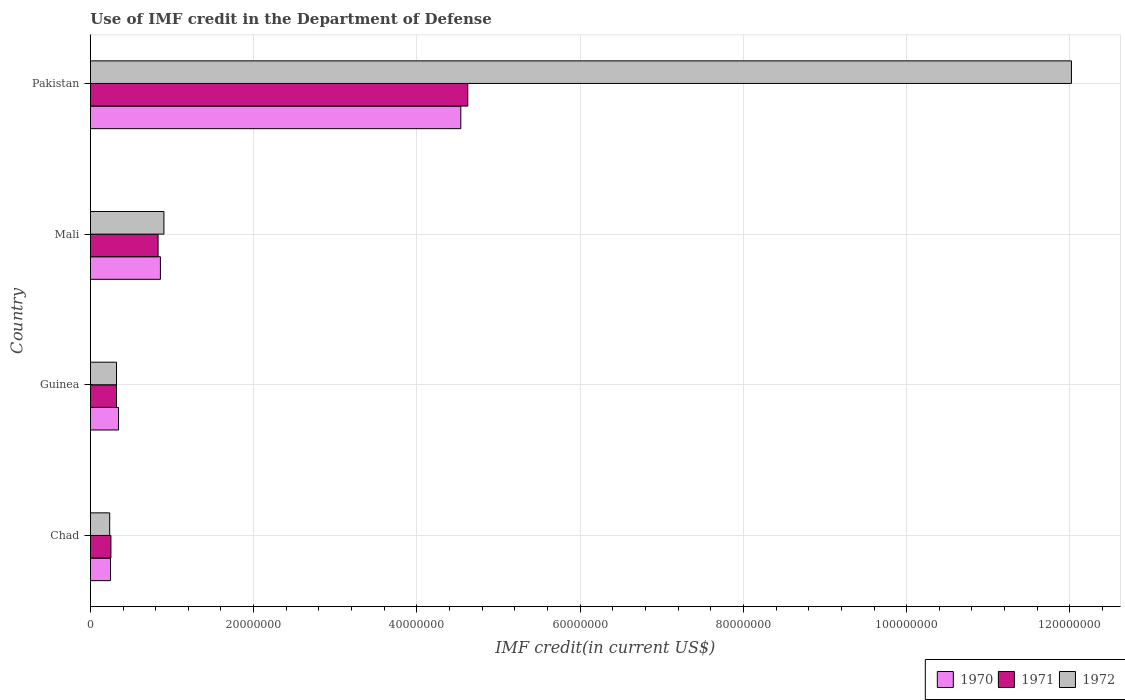Are the number of bars per tick equal to the number of legend labels?
Offer a terse response. Yes. Are the number of bars on each tick of the Y-axis equal?
Offer a very short reply. Yes. How many bars are there on the 1st tick from the top?
Offer a very short reply. 3. How many bars are there on the 1st tick from the bottom?
Offer a very short reply. 3. What is the label of the 3rd group of bars from the top?
Provide a succinct answer. Guinea. What is the IMF credit in the Department of Defense in 1970 in Pakistan?
Keep it short and to the point. 4.54e+07. Across all countries, what is the maximum IMF credit in the Department of Defense in 1972?
Your answer should be very brief. 1.20e+08. Across all countries, what is the minimum IMF credit in the Department of Defense in 1972?
Offer a very short reply. 2.37e+06. In which country was the IMF credit in the Department of Defense in 1971 maximum?
Offer a very short reply. Pakistan. In which country was the IMF credit in the Department of Defense in 1971 minimum?
Offer a terse response. Chad. What is the total IMF credit in the Department of Defense in 1970 in the graph?
Provide a short and direct response. 5.99e+07. What is the difference between the IMF credit in the Department of Defense in 1972 in Chad and that in Guinea?
Ensure brevity in your answer.  -8.36e+05. What is the difference between the IMF credit in the Department of Defense in 1970 in Pakistan and the IMF credit in the Department of Defense in 1972 in Mali?
Provide a succinct answer. 3.64e+07. What is the average IMF credit in the Department of Defense in 1970 per country?
Your response must be concise. 1.50e+07. What is the difference between the IMF credit in the Department of Defense in 1971 and IMF credit in the Department of Defense in 1970 in Guinea?
Keep it short and to the point. -2.47e+05. What is the ratio of the IMF credit in the Department of Defense in 1970 in Chad to that in Pakistan?
Keep it short and to the point. 0.05. What is the difference between the highest and the second highest IMF credit in the Department of Defense in 1972?
Provide a succinct answer. 1.11e+08. What is the difference between the highest and the lowest IMF credit in the Department of Defense in 1972?
Your answer should be compact. 1.18e+08. Is the sum of the IMF credit in the Department of Defense in 1971 in Mali and Pakistan greater than the maximum IMF credit in the Department of Defense in 1972 across all countries?
Make the answer very short. No. Is it the case that in every country, the sum of the IMF credit in the Department of Defense in 1971 and IMF credit in the Department of Defense in 1972 is greater than the IMF credit in the Department of Defense in 1970?
Ensure brevity in your answer.  Yes. How many bars are there?
Provide a succinct answer. 12. Are all the bars in the graph horizontal?
Offer a very short reply. Yes. How many countries are there in the graph?
Offer a very short reply. 4. Does the graph contain grids?
Give a very brief answer. Yes. How are the legend labels stacked?
Keep it short and to the point. Horizontal. What is the title of the graph?
Offer a terse response. Use of IMF credit in the Department of Defense. What is the label or title of the X-axis?
Give a very brief answer. IMF credit(in current US$). What is the IMF credit(in current US$) in 1970 in Chad?
Make the answer very short. 2.47e+06. What is the IMF credit(in current US$) in 1971 in Chad?
Offer a terse response. 2.52e+06. What is the IMF credit(in current US$) of 1972 in Chad?
Provide a succinct answer. 2.37e+06. What is the IMF credit(in current US$) of 1970 in Guinea?
Keep it short and to the point. 3.45e+06. What is the IMF credit(in current US$) in 1971 in Guinea?
Your response must be concise. 3.20e+06. What is the IMF credit(in current US$) in 1972 in Guinea?
Offer a very short reply. 3.20e+06. What is the IMF credit(in current US$) in 1970 in Mali?
Your answer should be very brief. 8.58e+06. What is the IMF credit(in current US$) in 1971 in Mali?
Your response must be concise. 8.30e+06. What is the IMF credit(in current US$) in 1972 in Mali?
Your response must be concise. 9.01e+06. What is the IMF credit(in current US$) of 1970 in Pakistan?
Your response must be concise. 4.54e+07. What is the IMF credit(in current US$) in 1971 in Pakistan?
Provide a succinct answer. 4.62e+07. What is the IMF credit(in current US$) in 1972 in Pakistan?
Give a very brief answer. 1.20e+08. Across all countries, what is the maximum IMF credit(in current US$) in 1970?
Your answer should be very brief. 4.54e+07. Across all countries, what is the maximum IMF credit(in current US$) of 1971?
Give a very brief answer. 4.62e+07. Across all countries, what is the maximum IMF credit(in current US$) of 1972?
Make the answer very short. 1.20e+08. Across all countries, what is the minimum IMF credit(in current US$) in 1970?
Your answer should be very brief. 2.47e+06. Across all countries, what is the minimum IMF credit(in current US$) in 1971?
Provide a short and direct response. 2.52e+06. Across all countries, what is the minimum IMF credit(in current US$) of 1972?
Offer a very short reply. 2.37e+06. What is the total IMF credit(in current US$) of 1970 in the graph?
Your answer should be very brief. 5.99e+07. What is the total IMF credit(in current US$) in 1971 in the graph?
Give a very brief answer. 6.03e+07. What is the total IMF credit(in current US$) of 1972 in the graph?
Give a very brief answer. 1.35e+08. What is the difference between the IMF credit(in current US$) in 1970 in Chad and that in Guinea?
Give a very brief answer. -9.80e+05. What is the difference between the IMF credit(in current US$) in 1971 in Chad and that in Guinea?
Give a very brief answer. -6.84e+05. What is the difference between the IMF credit(in current US$) in 1972 in Chad and that in Guinea?
Your response must be concise. -8.36e+05. What is the difference between the IMF credit(in current US$) of 1970 in Chad and that in Mali?
Give a very brief answer. -6.11e+06. What is the difference between the IMF credit(in current US$) in 1971 in Chad and that in Mali?
Your response must be concise. -5.78e+06. What is the difference between the IMF credit(in current US$) of 1972 in Chad and that in Mali?
Ensure brevity in your answer.  -6.64e+06. What is the difference between the IMF credit(in current US$) in 1970 in Chad and that in Pakistan?
Provide a succinct answer. -4.29e+07. What is the difference between the IMF credit(in current US$) in 1971 in Chad and that in Pakistan?
Ensure brevity in your answer.  -4.37e+07. What is the difference between the IMF credit(in current US$) in 1972 in Chad and that in Pakistan?
Ensure brevity in your answer.  -1.18e+08. What is the difference between the IMF credit(in current US$) in 1970 in Guinea and that in Mali?
Offer a terse response. -5.13e+06. What is the difference between the IMF credit(in current US$) of 1971 in Guinea and that in Mali?
Provide a succinct answer. -5.09e+06. What is the difference between the IMF credit(in current US$) in 1972 in Guinea and that in Mali?
Your response must be concise. -5.81e+06. What is the difference between the IMF credit(in current US$) in 1970 in Guinea and that in Pakistan?
Keep it short and to the point. -4.19e+07. What is the difference between the IMF credit(in current US$) in 1971 in Guinea and that in Pakistan?
Your answer should be very brief. -4.30e+07. What is the difference between the IMF credit(in current US$) of 1972 in Guinea and that in Pakistan?
Ensure brevity in your answer.  -1.17e+08. What is the difference between the IMF credit(in current US$) of 1970 in Mali and that in Pakistan?
Provide a succinct answer. -3.68e+07. What is the difference between the IMF credit(in current US$) of 1971 in Mali and that in Pakistan?
Ensure brevity in your answer.  -3.79e+07. What is the difference between the IMF credit(in current US$) in 1972 in Mali and that in Pakistan?
Make the answer very short. -1.11e+08. What is the difference between the IMF credit(in current US$) in 1970 in Chad and the IMF credit(in current US$) in 1971 in Guinea?
Ensure brevity in your answer.  -7.33e+05. What is the difference between the IMF credit(in current US$) of 1970 in Chad and the IMF credit(in current US$) of 1972 in Guinea?
Give a very brief answer. -7.33e+05. What is the difference between the IMF credit(in current US$) of 1971 in Chad and the IMF credit(in current US$) of 1972 in Guinea?
Keep it short and to the point. -6.84e+05. What is the difference between the IMF credit(in current US$) in 1970 in Chad and the IMF credit(in current US$) in 1971 in Mali?
Offer a very short reply. -5.82e+06. What is the difference between the IMF credit(in current US$) in 1970 in Chad and the IMF credit(in current US$) in 1972 in Mali?
Provide a succinct answer. -6.54e+06. What is the difference between the IMF credit(in current US$) of 1971 in Chad and the IMF credit(in current US$) of 1972 in Mali?
Offer a very short reply. -6.49e+06. What is the difference between the IMF credit(in current US$) of 1970 in Chad and the IMF credit(in current US$) of 1971 in Pakistan?
Your answer should be very brief. -4.38e+07. What is the difference between the IMF credit(in current US$) in 1970 in Chad and the IMF credit(in current US$) in 1972 in Pakistan?
Ensure brevity in your answer.  -1.18e+08. What is the difference between the IMF credit(in current US$) in 1971 in Chad and the IMF credit(in current US$) in 1972 in Pakistan?
Your response must be concise. -1.18e+08. What is the difference between the IMF credit(in current US$) of 1970 in Guinea and the IMF credit(in current US$) of 1971 in Mali?
Ensure brevity in your answer.  -4.84e+06. What is the difference between the IMF credit(in current US$) of 1970 in Guinea and the IMF credit(in current US$) of 1972 in Mali?
Provide a short and direct response. -5.56e+06. What is the difference between the IMF credit(in current US$) of 1971 in Guinea and the IMF credit(in current US$) of 1972 in Mali?
Offer a very short reply. -5.81e+06. What is the difference between the IMF credit(in current US$) in 1970 in Guinea and the IMF credit(in current US$) in 1971 in Pakistan?
Offer a terse response. -4.28e+07. What is the difference between the IMF credit(in current US$) in 1970 in Guinea and the IMF credit(in current US$) in 1972 in Pakistan?
Your response must be concise. -1.17e+08. What is the difference between the IMF credit(in current US$) of 1971 in Guinea and the IMF credit(in current US$) of 1972 in Pakistan?
Offer a very short reply. -1.17e+08. What is the difference between the IMF credit(in current US$) of 1970 in Mali and the IMF credit(in current US$) of 1971 in Pakistan?
Your answer should be very brief. -3.77e+07. What is the difference between the IMF credit(in current US$) of 1970 in Mali and the IMF credit(in current US$) of 1972 in Pakistan?
Offer a very short reply. -1.12e+08. What is the difference between the IMF credit(in current US$) in 1971 in Mali and the IMF credit(in current US$) in 1972 in Pakistan?
Offer a terse response. -1.12e+08. What is the average IMF credit(in current US$) in 1970 per country?
Your answer should be compact. 1.50e+07. What is the average IMF credit(in current US$) of 1971 per country?
Keep it short and to the point. 1.51e+07. What is the average IMF credit(in current US$) in 1972 per country?
Your answer should be compact. 3.37e+07. What is the difference between the IMF credit(in current US$) in 1970 and IMF credit(in current US$) in 1971 in Chad?
Give a very brief answer. -4.90e+04. What is the difference between the IMF credit(in current US$) of 1970 and IMF credit(in current US$) of 1972 in Chad?
Your response must be concise. 1.03e+05. What is the difference between the IMF credit(in current US$) of 1971 and IMF credit(in current US$) of 1972 in Chad?
Provide a succinct answer. 1.52e+05. What is the difference between the IMF credit(in current US$) in 1970 and IMF credit(in current US$) in 1971 in Guinea?
Ensure brevity in your answer.  2.47e+05. What is the difference between the IMF credit(in current US$) in 1970 and IMF credit(in current US$) in 1972 in Guinea?
Ensure brevity in your answer.  2.47e+05. What is the difference between the IMF credit(in current US$) in 1971 and IMF credit(in current US$) in 1972 in Guinea?
Offer a terse response. 0. What is the difference between the IMF credit(in current US$) of 1970 and IMF credit(in current US$) of 1971 in Mali?
Ensure brevity in your answer.  2.85e+05. What is the difference between the IMF credit(in current US$) in 1970 and IMF credit(in current US$) in 1972 in Mali?
Your answer should be very brief. -4.31e+05. What is the difference between the IMF credit(in current US$) in 1971 and IMF credit(in current US$) in 1972 in Mali?
Offer a very short reply. -7.16e+05. What is the difference between the IMF credit(in current US$) of 1970 and IMF credit(in current US$) of 1971 in Pakistan?
Give a very brief answer. -8.56e+05. What is the difference between the IMF credit(in current US$) of 1970 and IMF credit(in current US$) of 1972 in Pakistan?
Your answer should be very brief. -7.48e+07. What is the difference between the IMF credit(in current US$) in 1971 and IMF credit(in current US$) in 1972 in Pakistan?
Provide a succinct answer. -7.40e+07. What is the ratio of the IMF credit(in current US$) in 1970 in Chad to that in Guinea?
Offer a very short reply. 0.72. What is the ratio of the IMF credit(in current US$) of 1971 in Chad to that in Guinea?
Offer a terse response. 0.79. What is the ratio of the IMF credit(in current US$) in 1972 in Chad to that in Guinea?
Ensure brevity in your answer.  0.74. What is the ratio of the IMF credit(in current US$) of 1970 in Chad to that in Mali?
Provide a short and direct response. 0.29. What is the ratio of the IMF credit(in current US$) of 1971 in Chad to that in Mali?
Make the answer very short. 0.3. What is the ratio of the IMF credit(in current US$) of 1972 in Chad to that in Mali?
Make the answer very short. 0.26. What is the ratio of the IMF credit(in current US$) of 1970 in Chad to that in Pakistan?
Provide a short and direct response. 0.05. What is the ratio of the IMF credit(in current US$) of 1971 in Chad to that in Pakistan?
Provide a succinct answer. 0.05. What is the ratio of the IMF credit(in current US$) of 1972 in Chad to that in Pakistan?
Keep it short and to the point. 0.02. What is the ratio of the IMF credit(in current US$) in 1970 in Guinea to that in Mali?
Keep it short and to the point. 0.4. What is the ratio of the IMF credit(in current US$) in 1971 in Guinea to that in Mali?
Your answer should be very brief. 0.39. What is the ratio of the IMF credit(in current US$) in 1972 in Guinea to that in Mali?
Your answer should be very brief. 0.36. What is the ratio of the IMF credit(in current US$) in 1970 in Guinea to that in Pakistan?
Your response must be concise. 0.08. What is the ratio of the IMF credit(in current US$) of 1971 in Guinea to that in Pakistan?
Make the answer very short. 0.07. What is the ratio of the IMF credit(in current US$) in 1972 in Guinea to that in Pakistan?
Make the answer very short. 0.03. What is the ratio of the IMF credit(in current US$) of 1970 in Mali to that in Pakistan?
Provide a succinct answer. 0.19. What is the ratio of the IMF credit(in current US$) of 1971 in Mali to that in Pakistan?
Provide a short and direct response. 0.18. What is the ratio of the IMF credit(in current US$) of 1972 in Mali to that in Pakistan?
Your answer should be very brief. 0.07. What is the difference between the highest and the second highest IMF credit(in current US$) in 1970?
Provide a succinct answer. 3.68e+07. What is the difference between the highest and the second highest IMF credit(in current US$) of 1971?
Make the answer very short. 3.79e+07. What is the difference between the highest and the second highest IMF credit(in current US$) of 1972?
Offer a very short reply. 1.11e+08. What is the difference between the highest and the lowest IMF credit(in current US$) of 1970?
Your answer should be compact. 4.29e+07. What is the difference between the highest and the lowest IMF credit(in current US$) in 1971?
Your response must be concise. 4.37e+07. What is the difference between the highest and the lowest IMF credit(in current US$) in 1972?
Make the answer very short. 1.18e+08. 